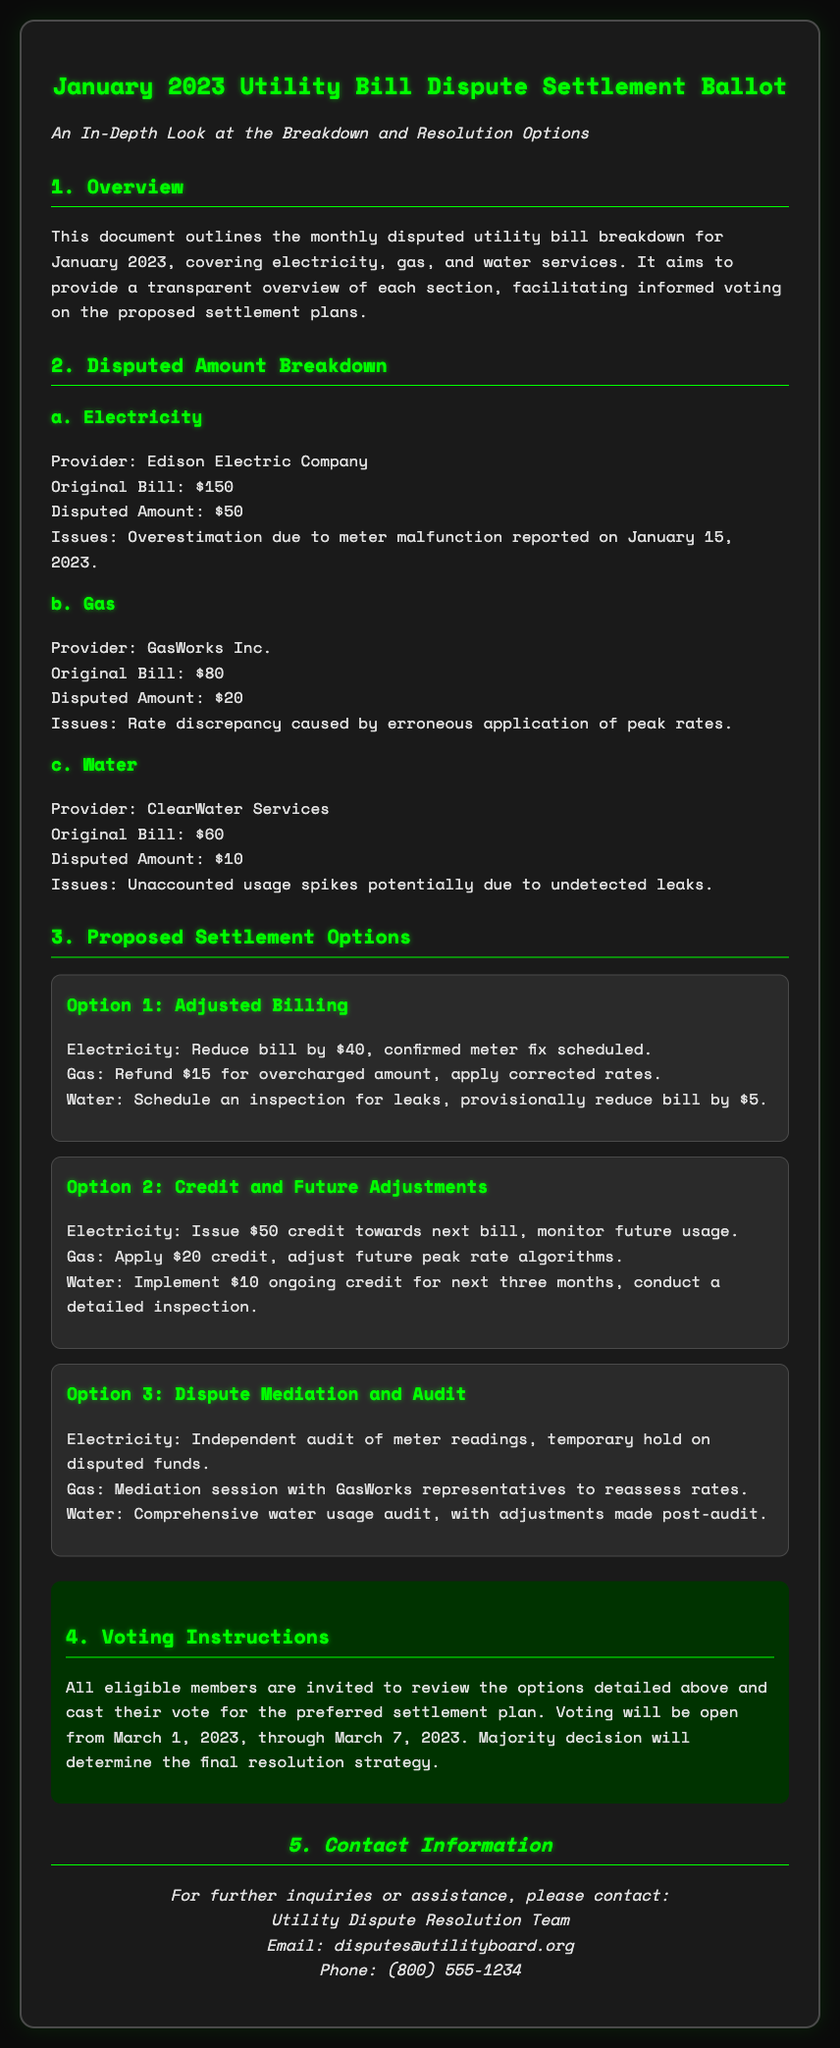What is the total disputed amount for electricity? The disputed amount for electricity is specified as $50 in the document.
Answer: $50 What is the provider for water services? The document states that the provider for water services is ClearWater Services.
Answer: ClearWater Services What adjustment is proposed for the gas bill in Option 1? Option 1 proposes a refund of $15 for the gas bill due to the overcharged amount.
Answer: $15 How long will voting be open? The document indicates that voting will be open from March 1, 2023, through March 7, 2023.
Answer: 7 days What is the maximum refund for electricity in Option 2? Option 2 specifies an issue of a $50 credit towards the next bill for electricity.
Answer: $50 What issue caused the disputed amount for gas? The document mentions that the disputed amount for gas was caused by erroneous application of peak rates.
Answer: Erroneous application of peak rates What is the contact email provided for inquiries? The contact email listed for inquiries is disputes@utilityboard.org.
Answer: disputes@utilityboard.org What type of audit is proposed for electricity in Option 3? The proposed audit for electricity in Option 3 is an independent audit of meter readings.
Answer: Independent audit What provision is made for water usage in Option 2? Option 2 proposes a $10 ongoing credit for water for the next three months along with a detailed inspection.
Answer: $10 ongoing credit for next three months 